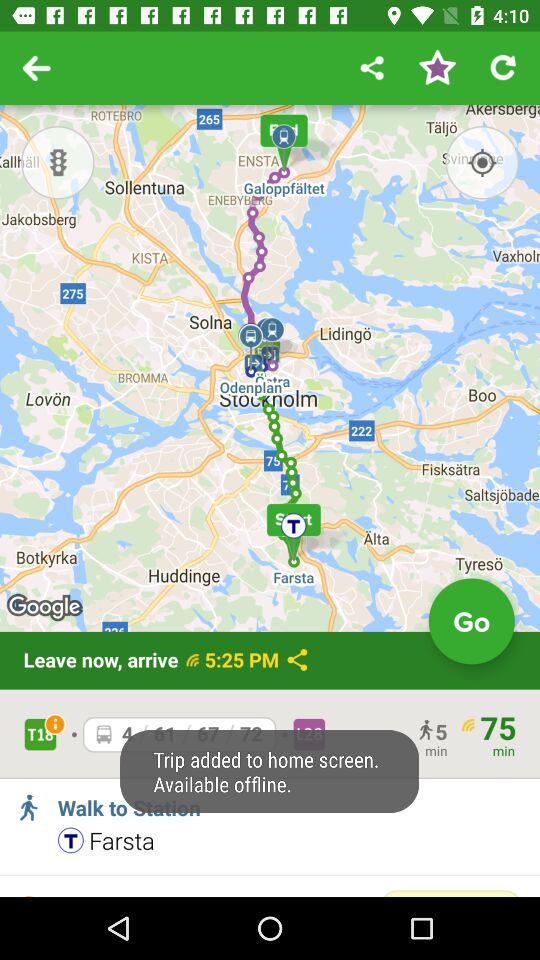How much time will it take to walk to the Farsta station? It will take 5 minutes. 